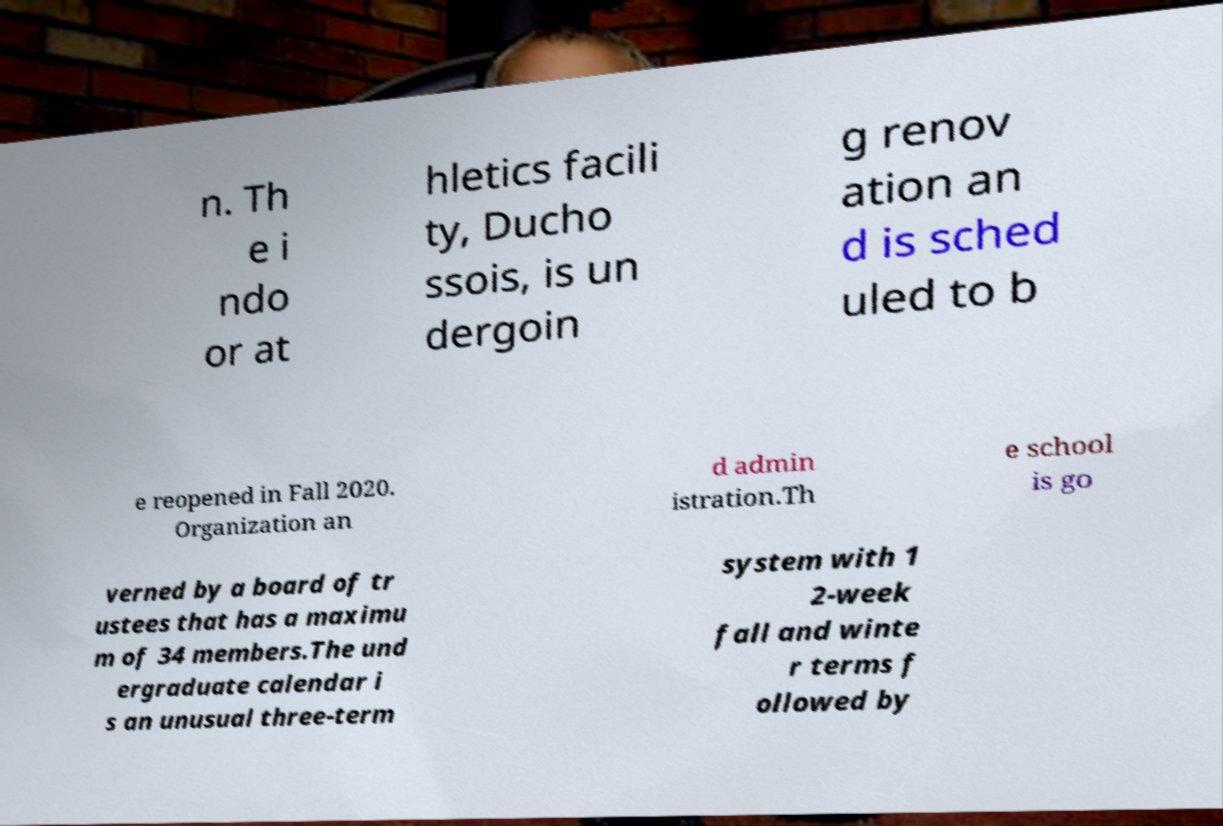For documentation purposes, I need the text within this image transcribed. Could you provide that? n. Th e i ndo or at hletics facili ty, Ducho ssois, is un dergoin g renov ation an d is sched uled to b e reopened in Fall 2020. Organization an d admin istration.Th e school is go verned by a board of tr ustees that has a maximu m of 34 members.The und ergraduate calendar i s an unusual three-term system with 1 2-week fall and winte r terms f ollowed by 